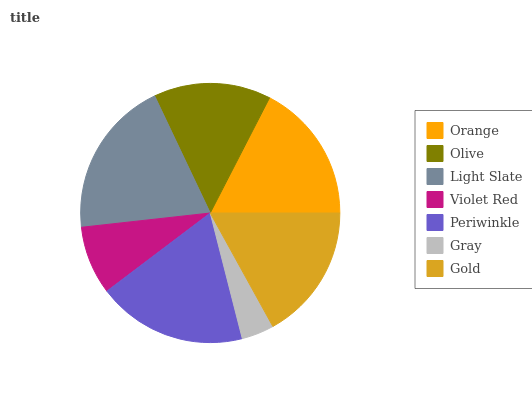Is Gray the minimum?
Answer yes or no. Yes. Is Light Slate the maximum?
Answer yes or no. Yes. Is Olive the minimum?
Answer yes or no. No. Is Olive the maximum?
Answer yes or no. No. Is Orange greater than Olive?
Answer yes or no. Yes. Is Olive less than Orange?
Answer yes or no. Yes. Is Olive greater than Orange?
Answer yes or no. No. Is Orange less than Olive?
Answer yes or no. No. Is Gold the high median?
Answer yes or no. Yes. Is Gold the low median?
Answer yes or no. Yes. Is Orange the high median?
Answer yes or no. No. Is Periwinkle the low median?
Answer yes or no. No. 